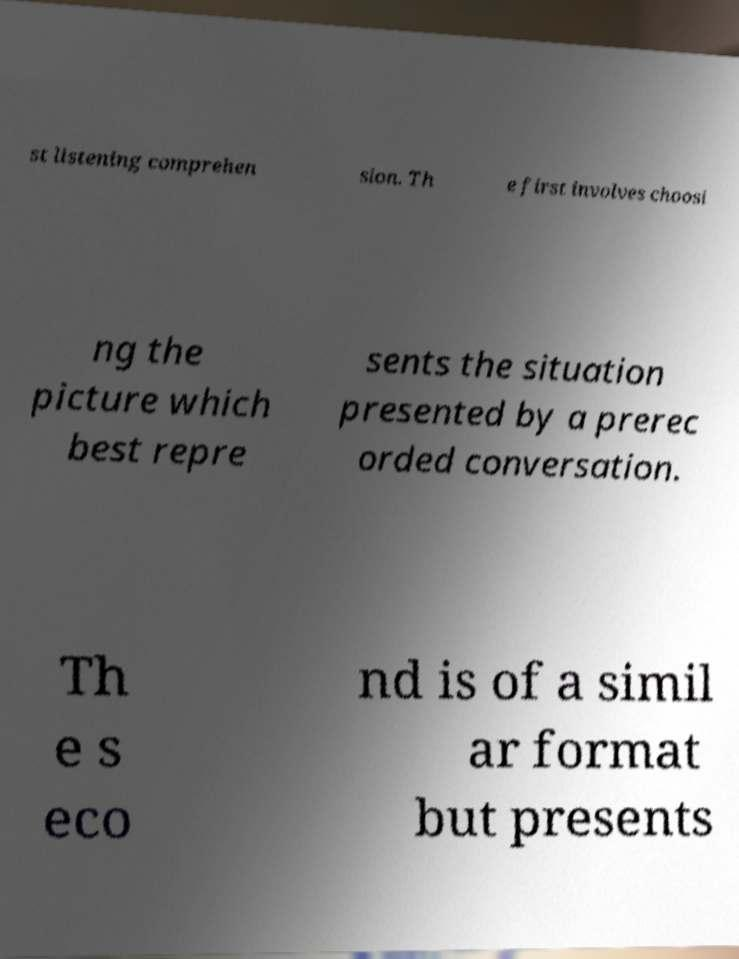There's text embedded in this image that I need extracted. Can you transcribe it verbatim? st listening comprehen sion. Th e first involves choosi ng the picture which best repre sents the situation presented by a prerec orded conversation. Th e s eco nd is of a simil ar format but presents 